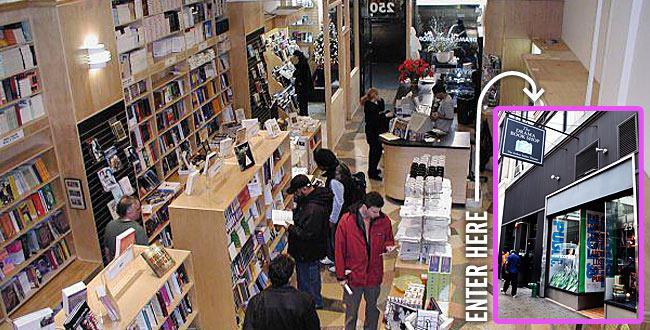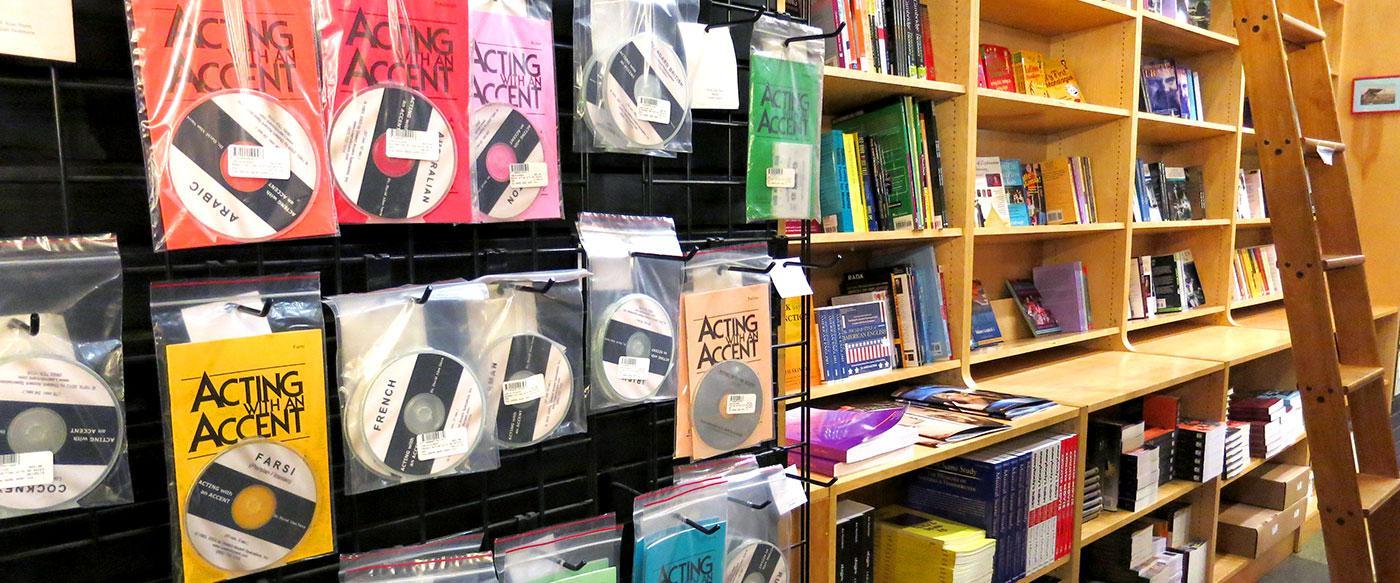The first image is the image on the left, the second image is the image on the right. For the images displayed, is the sentence "An image shows the interior of a bookstore, with cluster of shoppers not behind glass." factually correct? Answer yes or no. Yes. The first image is the image on the left, the second image is the image on the right. Considering the images on both sides, is "There are no people in the image on the left" valid? Answer yes or no. No. 